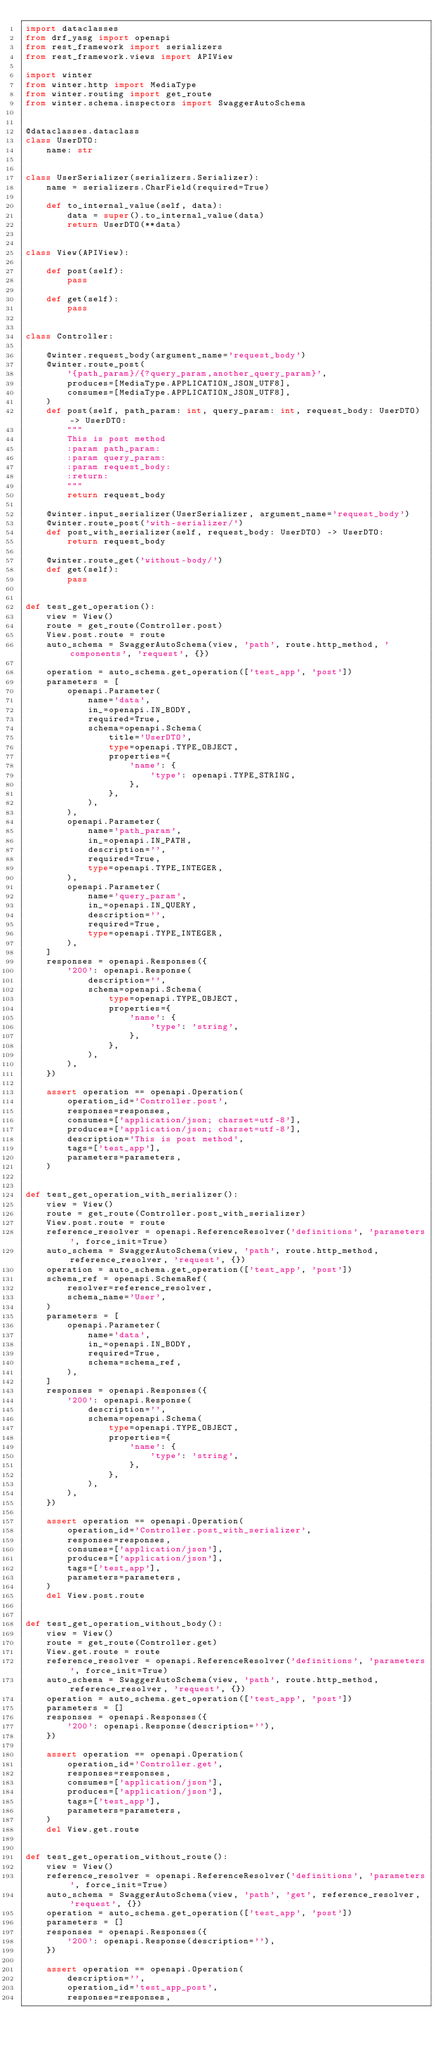<code> <loc_0><loc_0><loc_500><loc_500><_Python_>import dataclasses
from drf_yasg import openapi
from rest_framework import serializers
from rest_framework.views import APIView

import winter
from winter.http import MediaType
from winter.routing import get_route
from winter.schema.inspectors import SwaggerAutoSchema


@dataclasses.dataclass
class UserDTO:
    name: str


class UserSerializer(serializers.Serializer):
    name = serializers.CharField(required=True)

    def to_internal_value(self, data):
        data = super().to_internal_value(data)
        return UserDTO(**data)


class View(APIView):

    def post(self):
        pass

    def get(self):
        pass


class Controller:

    @winter.request_body(argument_name='request_body')
    @winter.route_post(
        '{path_param}/{?query_param,another_query_param}',
        produces=[MediaType.APPLICATION_JSON_UTF8],
        consumes=[MediaType.APPLICATION_JSON_UTF8],
    )
    def post(self, path_param: int, query_param: int, request_body: UserDTO) -> UserDTO:
        """
        This is post method
        :param path_param:
        :param query_param:
        :param request_body:
        :return:
        """
        return request_body

    @winter.input_serializer(UserSerializer, argument_name='request_body')
    @winter.route_post('with-serializer/')
    def post_with_serializer(self, request_body: UserDTO) -> UserDTO:
        return request_body

    @winter.route_get('without-body/')
    def get(self):
        pass


def test_get_operation():
    view = View()
    route = get_route(Controller.post)
    View.post.route = route
    auto_schema = SwaggerAutoSchema(view, 'path', route.http_method, 'components', 'request', {})

    operation = auto_schema.get_operation(['test_app', 'post'])
    parameters = [
        openapi.Parameter(
            name='data',
            in_=openapi.IN_BODY,
            required=True,
            schema=openapi.Schema(
                title='UserDTO',
                type=openapi.TYPE_OBJECT,
                properties={
                    'name': {
                        'type': openapi.TYPE_STRING,
                    },
                },
            ),
        ),
        openapi.Parameter(
            name='path_param',
            in_=openapi.IN_PATH,
            description='',
            required=True,
            type=openapi.TYPE_INTEGER,
        ),
        openapi.Parameter(
            name='query_param',
            in_=openapi.IN_QUERY,
            description='',
            required=True,
            type=openapi.TYPE_INTEGER,
        ),
    ]
    responses = openapi.Responses({
        '200': openapi.Response(
            description='',
            schema=openapi.Schema(
                type=openapi.TYPE_OBJECT,
                properties={
                    'name': {
                        'type': 'string',
                    },
                },
            ),
        ),
    })

    assert operation == openapi.Operation(
        operation_id='Controller.post',
        responses=responses,
        consumes=['application/json; charset=utf-8'],
        produces=['application/json; charset=utf-8'],
        description='This is post method',
        tags=['test_app'],
        parameters=parameters,
    )


def test_get_operation_with_serializer():
    view = View()
    route = get_route(Controller.post_with_serializer)
    View.post.route = route
    reference_resolver = openapi.ReferenceResolver('definitions', 'parameters', force_init=True)
    auto_schema = SwaggerAutoSchema(view, 'path', route.http_method, reference_resolver, 'request', {})
    operation = auto_schema.get_operation(['test_app', 'post'])
    schema_ref = openapi.SchemaRef(
        resolver=reference_resolver,
        schema_name='User',
    )
    parameters = [
        openapi.Parameter(
            name='data',
            in_=openapi.IN_BODY,
            required=True,
            schema=schema_ref,
        ),
    ]
    responses = openapi.Responses({
        '200': openapi.Response(
            description='',
            schema=openapi.Schema(
                type=openapi.TYPE_OBJECT,
                properties={
                    'name': {
                        'type': 'string',
                    },
                },
            ),
        ),
    })

    assert operation == openapi.Operation(
        operation_id='Controller.post_with_serializer',
        responses=responses,
        consumes=['application/json'],
        produces=['application/json'],
        tags=['test_app'],
        parameters=parameters,
    )
    del View.post.route


def test_get_operation_without_body():
    view = View()
    route = get_route(Controller.get)
    View.get.route = route
    reference_resolver = openapi.ReferenceResolver('definitions', 'parameters', force_init=True)
    auto_schema = SwaggerAutoSchema(view, 'path', route.http_method, reference_resolver, 'request', {})
    operation = auto_schema.get_operation(['test_app', 'post'])
    parameters = []
    responses = openapi.Responses({
        '200': openapi.Response(description=''),
    })

    assert operation == openapi.Operation(
        operation_id='Controller.get',
        responses=responses,
        consumes=['application/json'],
        produces=['application/json'],
        tags=['test_app'],
        parameters=parameters,
    )
    del View.get.route


def test_get_operation_without_route():
    view = View()
    reference_resolver = openapi.ReferenceResolver('definitions', 'parameters', force_init=True)
    auto_schema = SwaggerAutoSchema(view, 'path', 'get', reference_resolver, 'request', {})
    operation = auto_schema.get_operation(['test_app', 'post'])
    parameters = []
    responses = openapi.Responses({
        '200': openapi.Response(description=''),
    })

    assert operation == openapi.Operation(
        description='',
        operation_id='test_app_post',
        responses=responses,</code> 